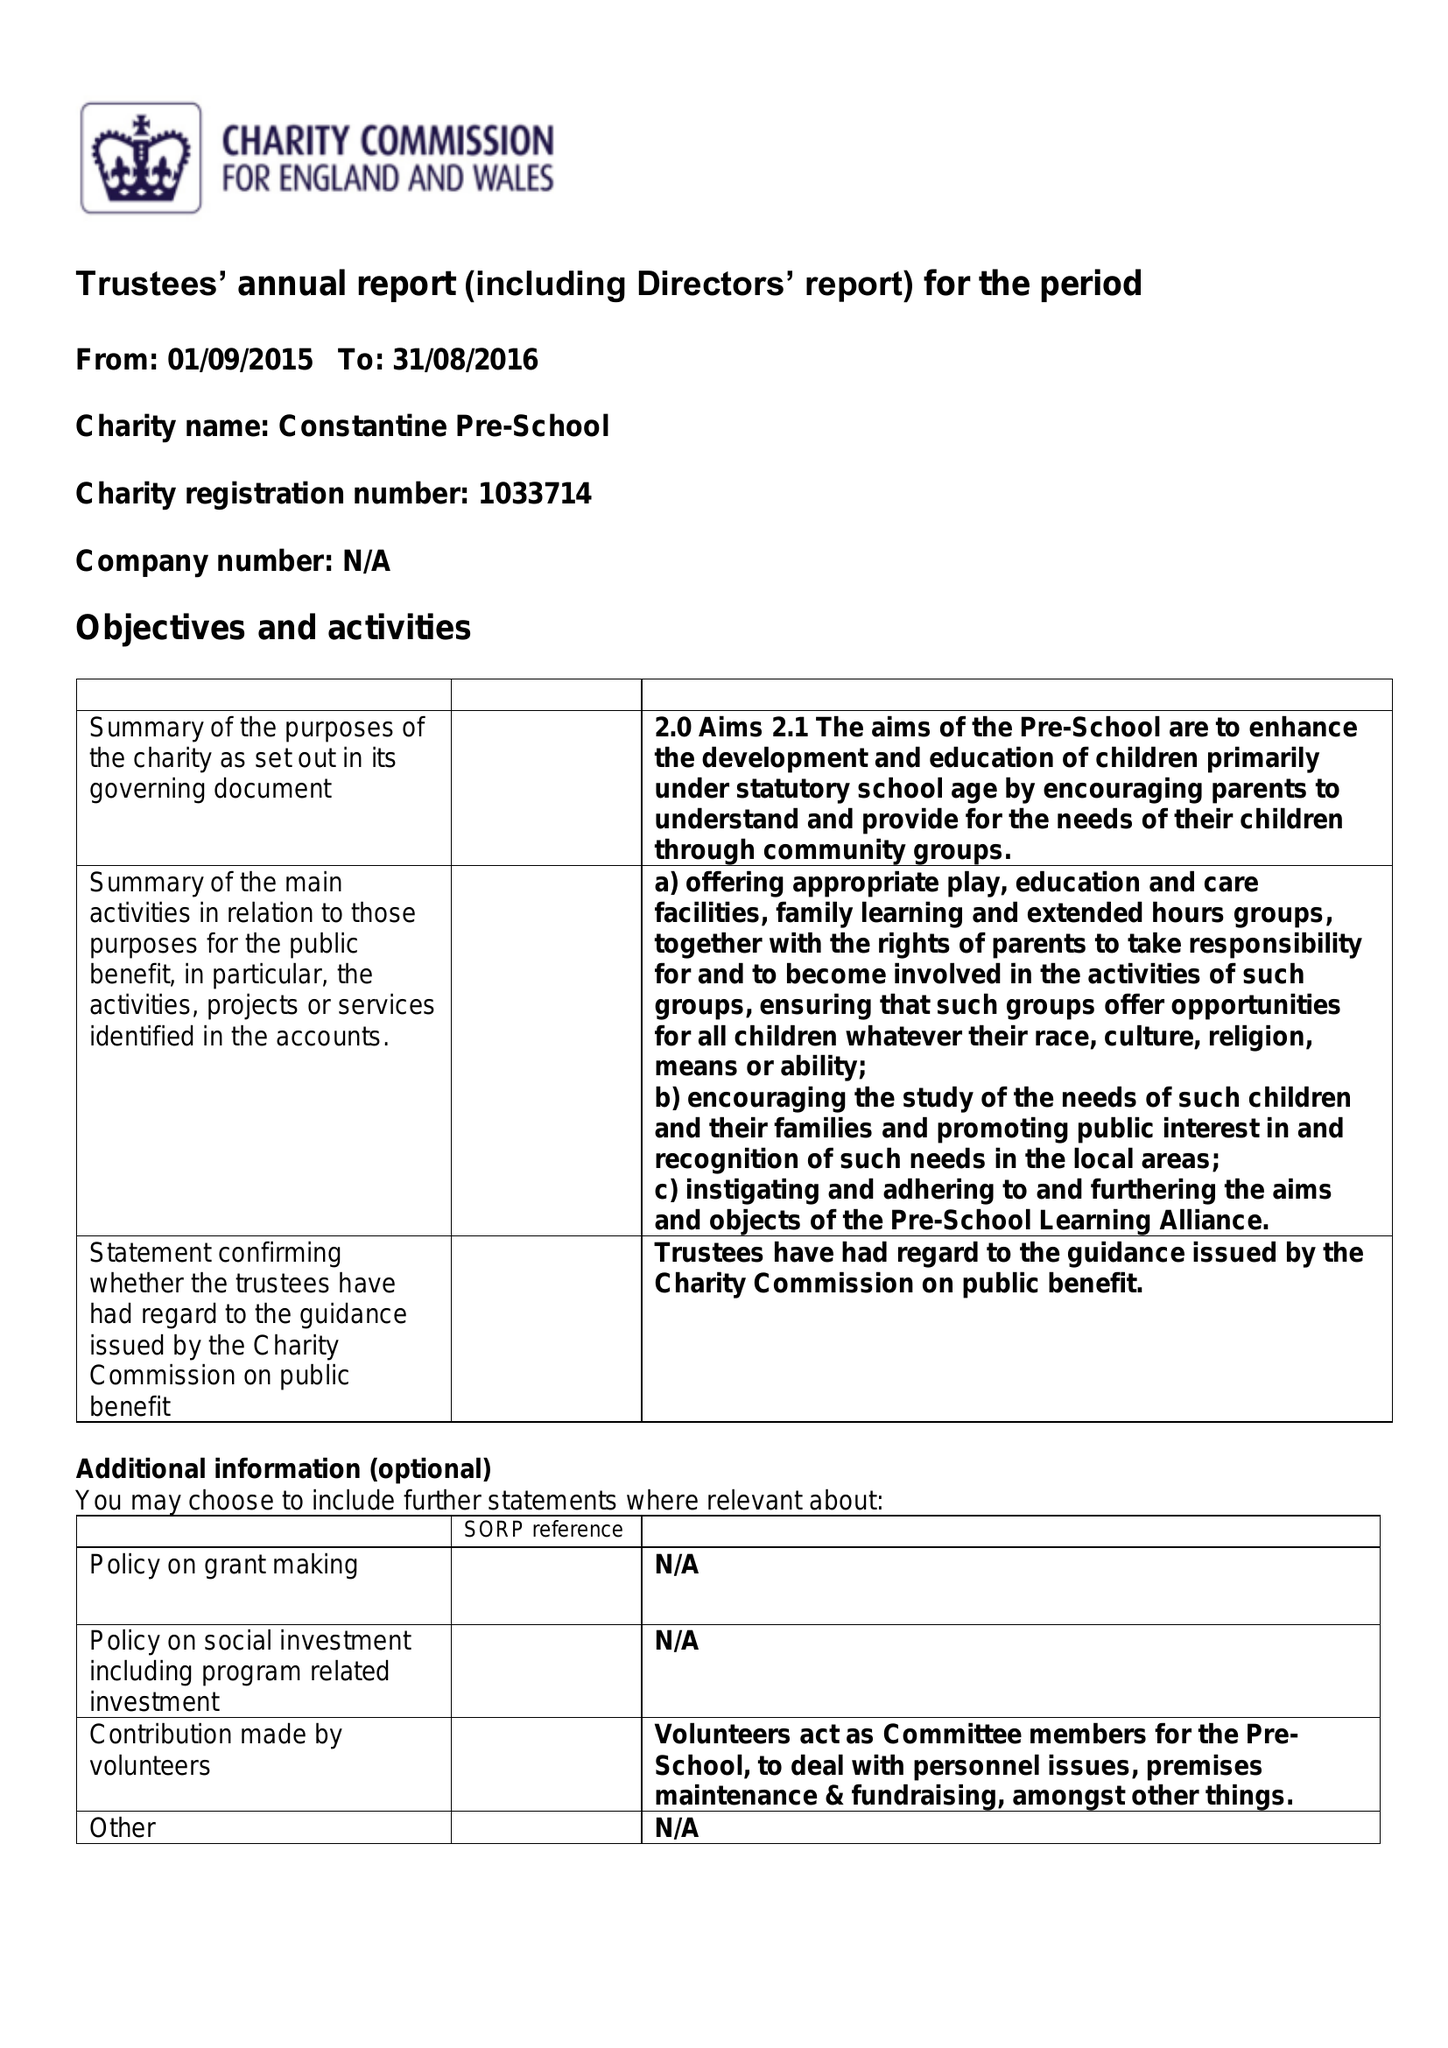What is the value for the charity_name?
Answer the question using a single word or phrase. Constantine Pre-School 